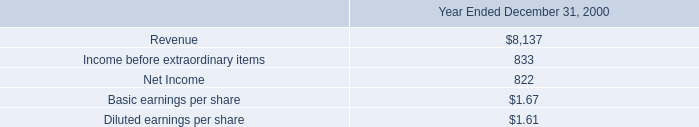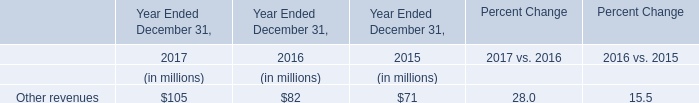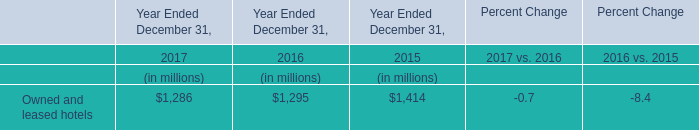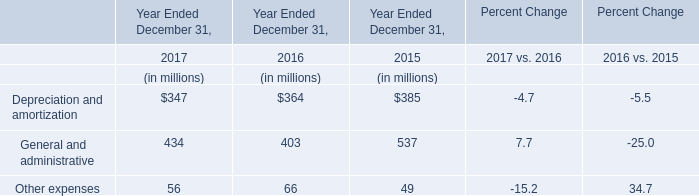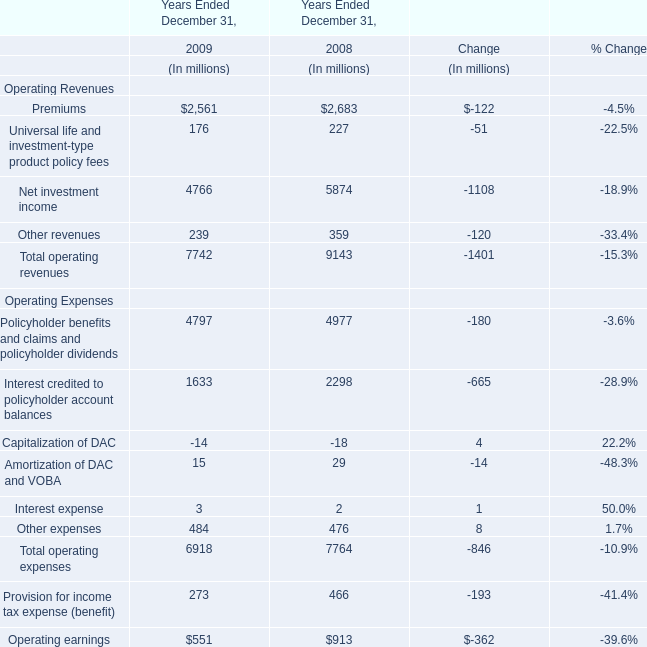What is the total value of the Net investment income, the Other revenues, the Total operating revenues and the Operating earnings for the year ended December 31, 2008? (in million) 
Computations: (((5874 + 359) + 9143) + 913)
Answer: 16289.0. 